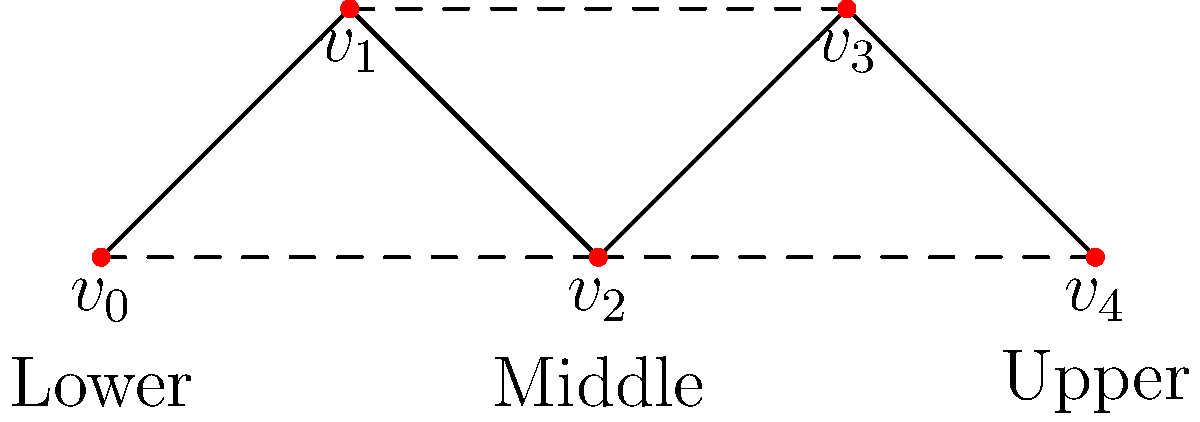In the context of social network connectivity across economic strata, analyze the graph above. If each vertex represents an individual and edges represent social connections, what is the minimum number of connections that need to be removed to disconnect the upper economic stratum (represented by $v_4$) from the lower economic stratum (represented by $v_0$)? To solve this problem, we need to follow these steps:

1. Identify the paths connecting the lower economic stratum ($v_0$) to the upper economic stratum ($v_4$):
   - Path 1: $v_0 - v_1 - v_2 - v_3 - v_4$
   - Path 2: $v_0 - v_2 - v_4$

2. Analyze the minimum number of edges to be removed to disconnect these paths:
   - To disconnect Path 1, we need to remove at least one edge from $v_0 - v_1 - v_2 - v_3 - v_4$
   - To disconnect Path 2, we need to remove the edge $v_2 - v_4$

3. Determine the most efficient way to disconnect both paths:
   - Removing the edge $v_2 - v_4$ disconnects both paths simultaneously

4. Count the number of edges that need to be removed:
   - Only one edge ($v_2 - v_4$) needs to be removed

Therefore, the minimum number of connections that need to be removed to disconnect the upper economic stratum from the lower economic stratum is 1.
Answer: 1 